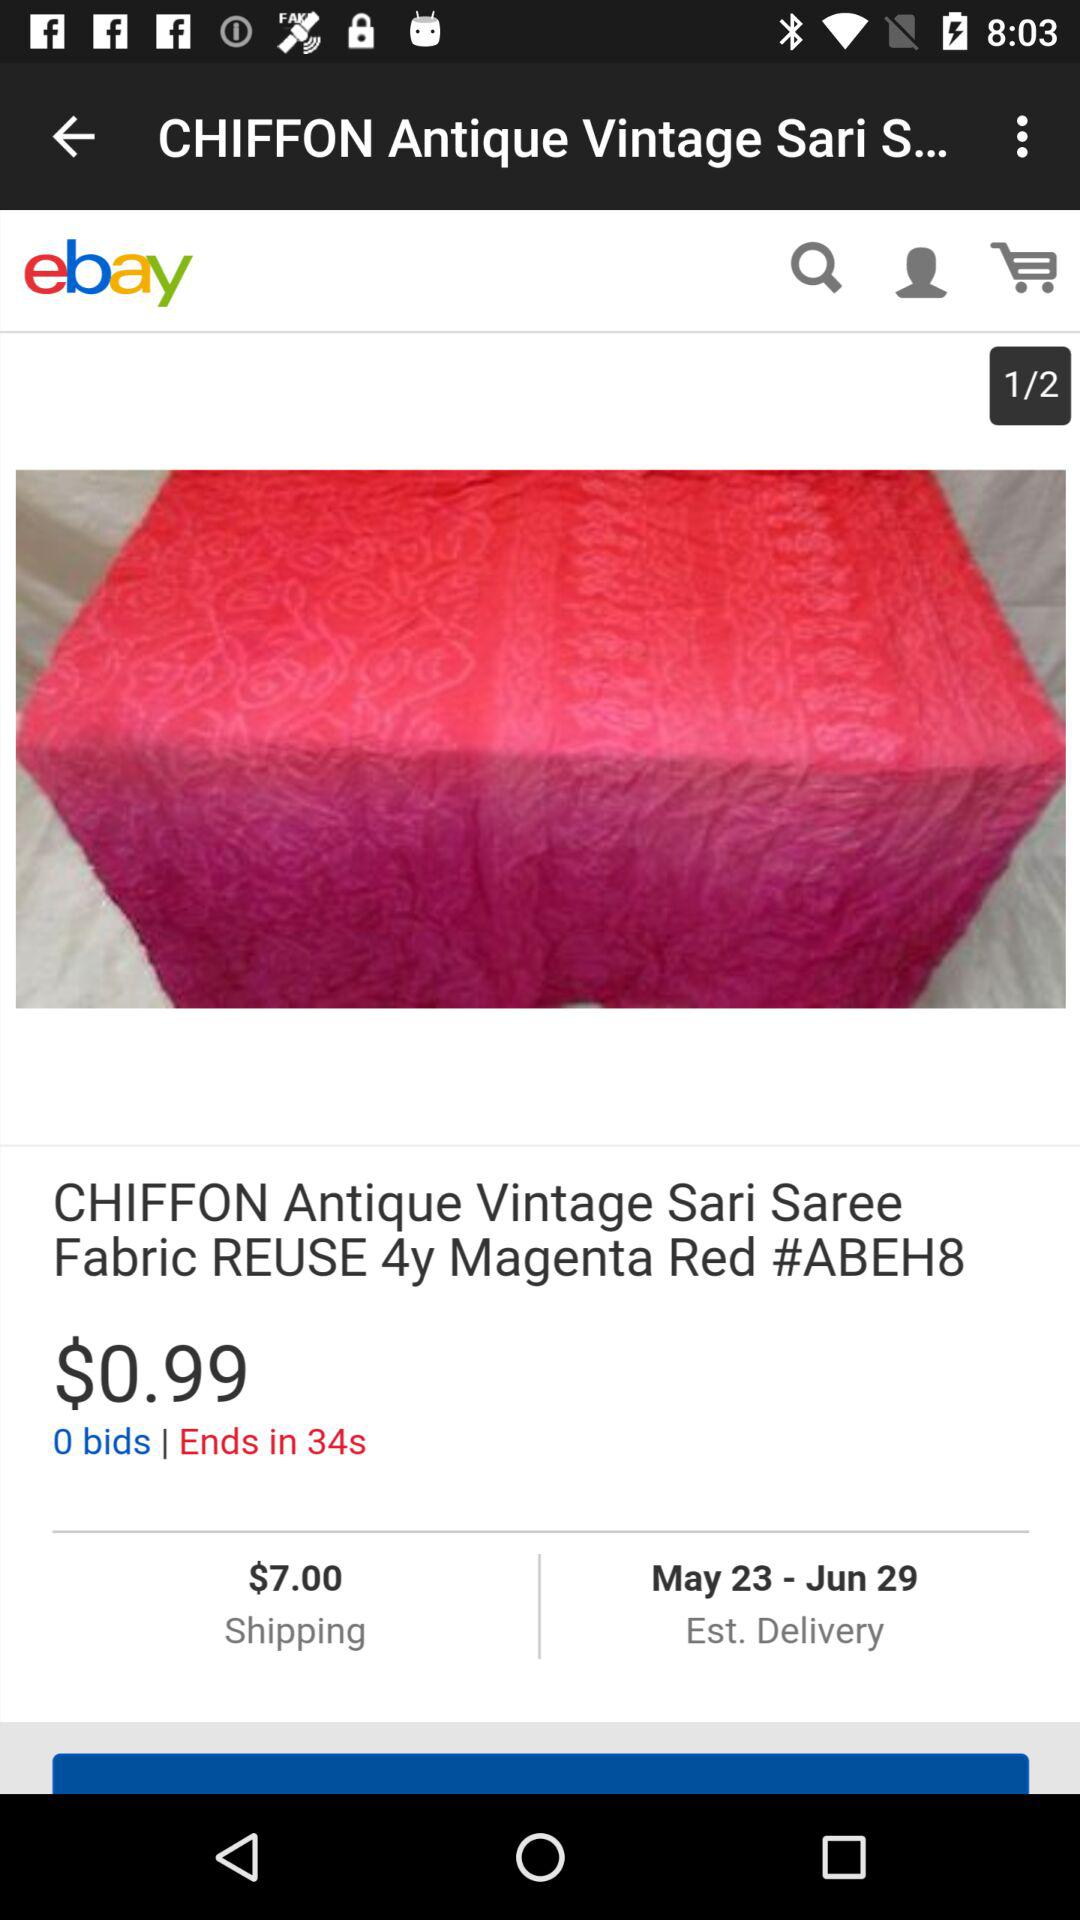What is the name of the application? The name of the application is "ebay". 